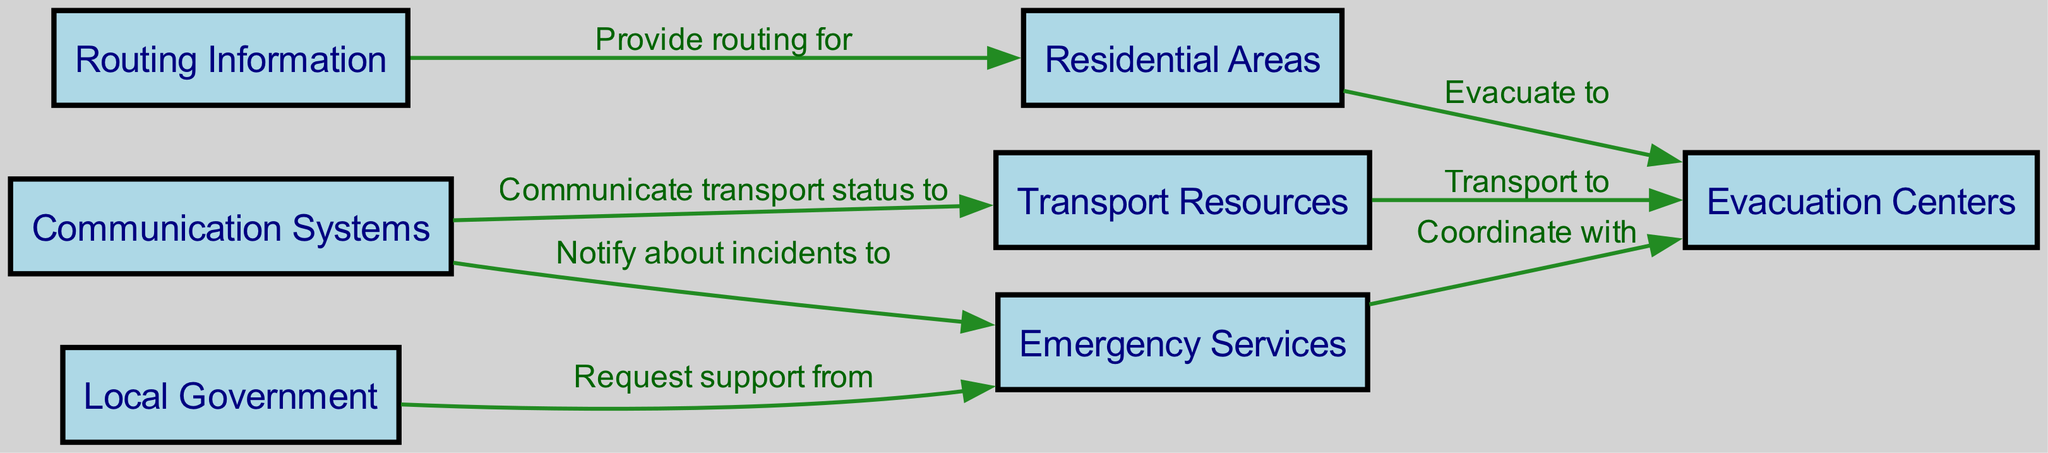What nodes are connected to Evacuation Centers? To find the nodes connected to Evacuation Centers, we look at the edges in the diagram. The edges with "Evacuation Centers" as the target are from Residential Areas (evacuate to), Emergency Services (coordinate with), and Transport Resources (transport to).
Answer: Residential Areas, Emergency Services, Transport Resources How many nodes are present in the diagram? The number of nodes can be determined by counting the nodes listed in the diagram. There are 7 distinct nodes: Evacuation Centers, Residential Areas, Emergency Services, Routing Information, Communication Systems, Transport Resources, and Local Government.
Answer: 7 What is the relationship between Communication Systems and Emergency Services? In the diagram, the edge going from Communication Systems to Emergency Services is labeled "Notify about incidents to." This indicates that Communication Systems provide notifications regarding incidents to Emergency Services.
Answer: Notify about incidents to Which node is responsible for providing routing information? To identify the node responsible for providing routing information, examine the outgoing edges. Routing Information provides routing for Residential Areas, meaning its role is to direct residents to evacuate safely.
Answer: Routing Information How many edges originate from Local Government? The edges originating from Local Government can be counted by examining the edges that have Local Government as the source. There is 1 edge leading from Local Government to Emergency Services, labeled "Request support from."
Answer: 1 What does Transport Resources communicate to Communication Systems? The edge between Transport Resources and Communication Systems is labeled "Communicate transport status to." This indicates that Transport Resources are responsible for updating Communication Systems regarding the transport situation during an evacuation.
Answer: Communicate transport status to What is the flow from Residential Areas to Evacuation Centers? The flow from Residential Areas to Evacuation Centers is indicated by the edge labeled "Evacuate to." This suggests that residents from Residential Areas are directed to evacuate to Evacuation Centers in case of a disaster.
Answer: Evacuate to What is the significance of Routing Information in the evacuation process? Routing Information plays a crucial role as it provides the necessary routing for Residential Areas, which assists in determining safe paths for evacuating residents. It ensures effective navigation away from danger.
Answer: Provide routing for Which departments need to coordinate during an evacuation? The departments that need to coordinate during an evacuation are Emergency Services and Evacuation Centers. Emergency Services coordinate with Evacuation Centers to ensure organized and timely evacuations.
Answer: Emergency Services, Evacuation Centers 